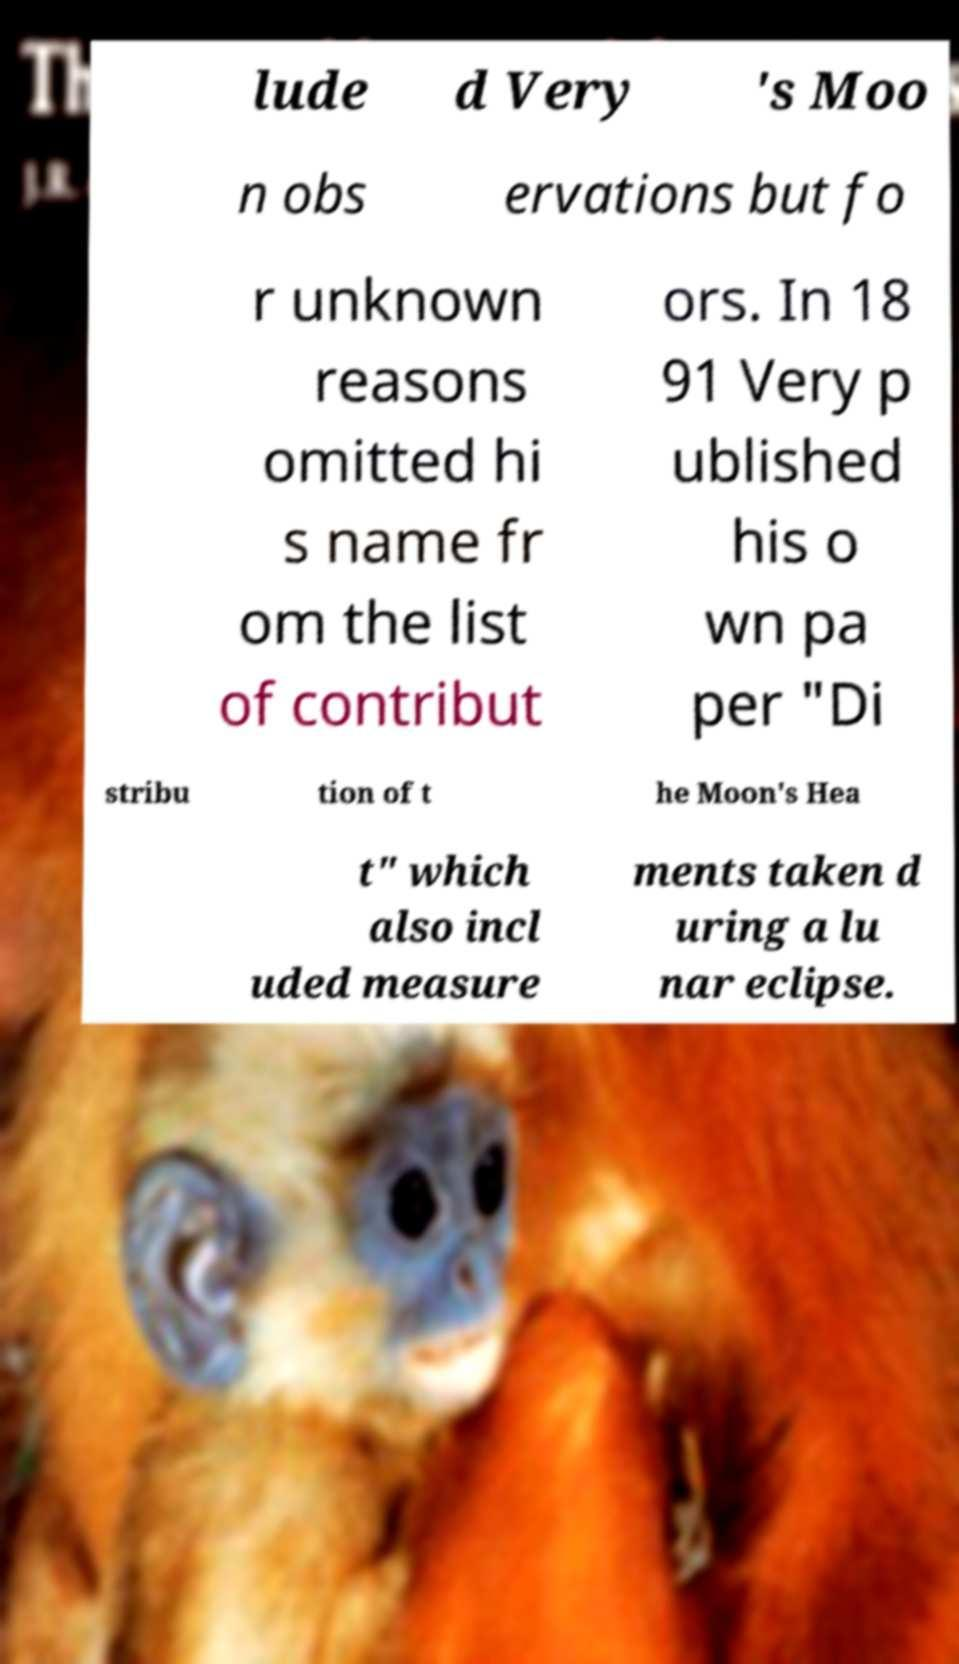What messages or text are displayed in this image? I need them in a readable, typed format. lude d Very 's Moo n obs ervations but fo r unknown reasons omitted hi s name fr om the list of contribut ors. In 18 91 Very p ublished his o wn pa per "Di stribu tion of t he Moon's Hea t" which also incl uded measure ments taken d uring a lu nar eclipse. 